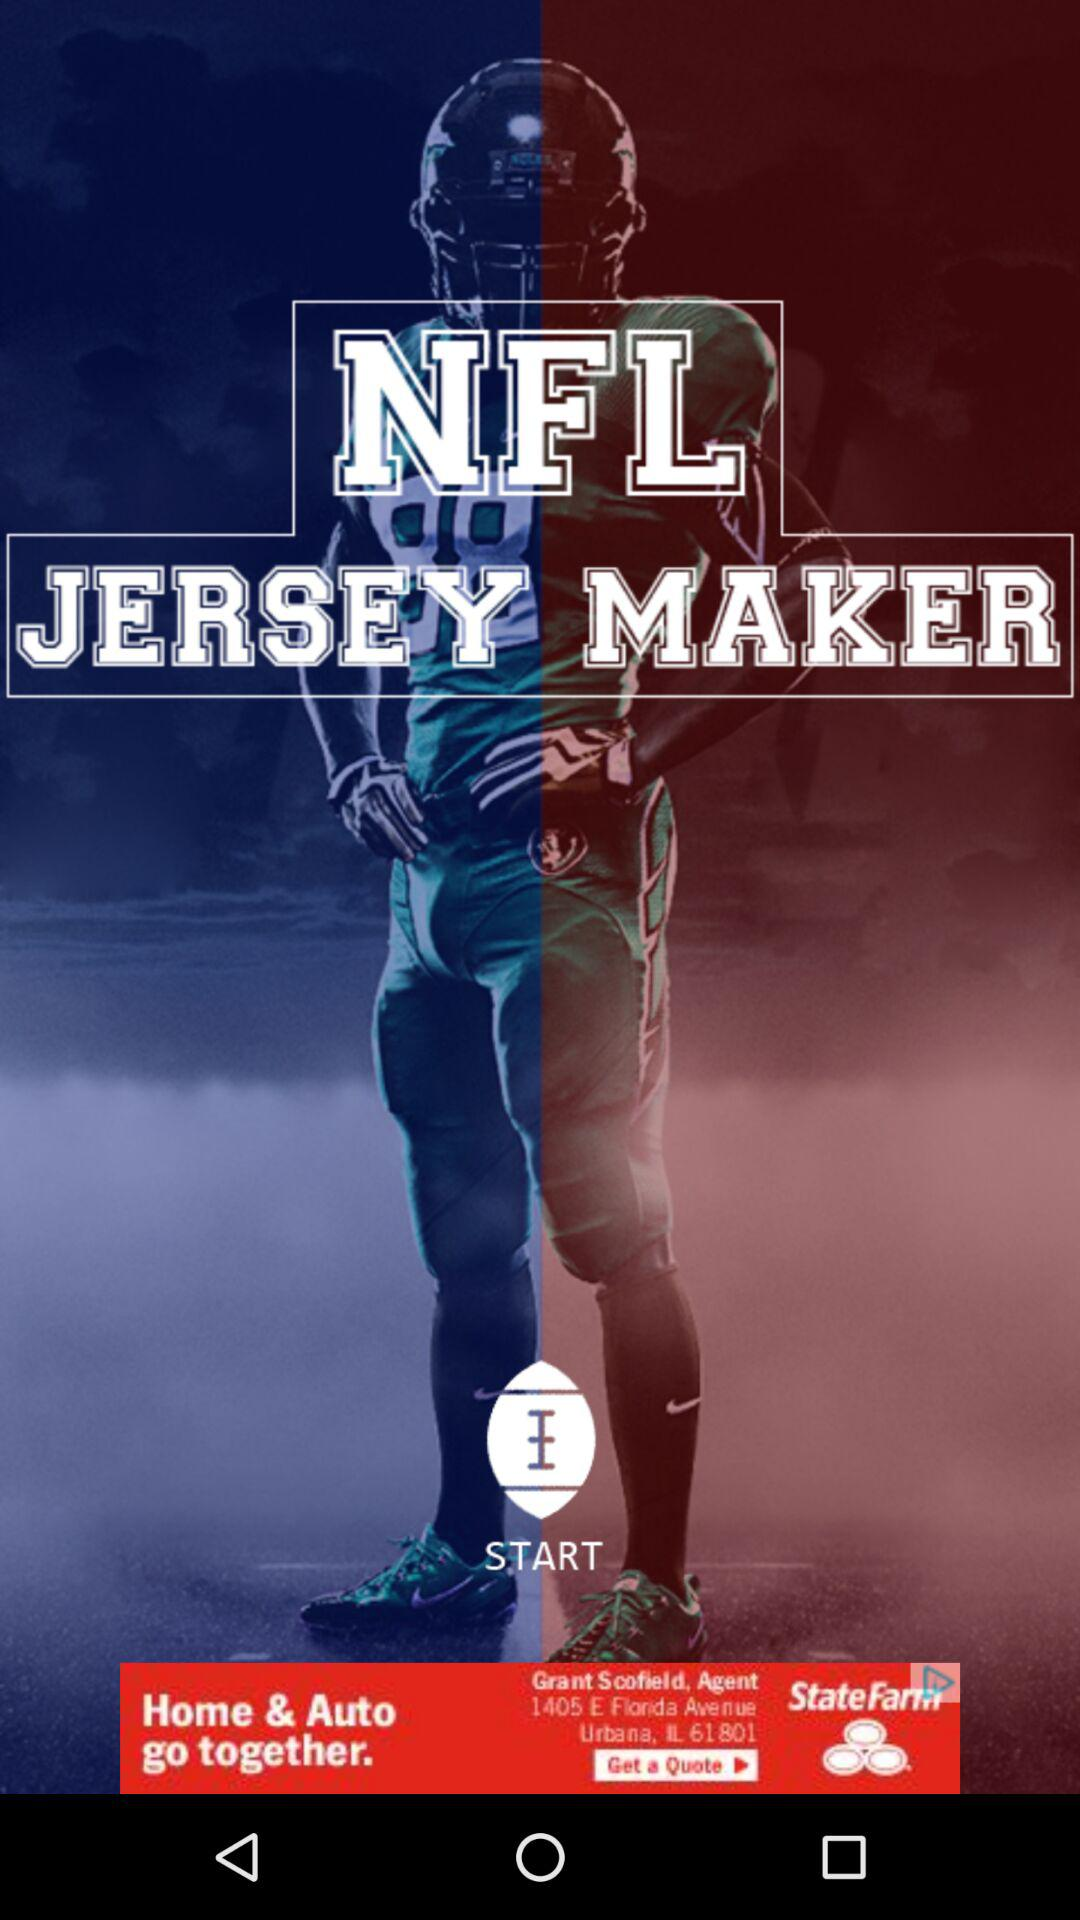What is the name of the application? The name of the application is "NFL JERSEY MAKER". 